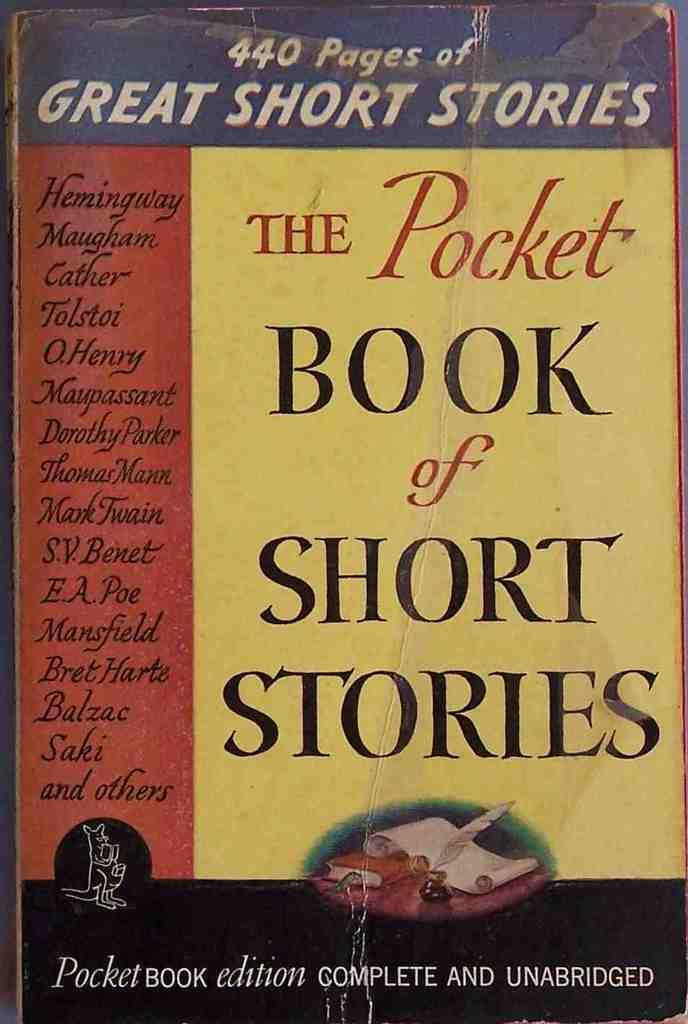<image>
Present a compact description of the photo's key features. The front cover of the book titled The pocket book of short stories. 